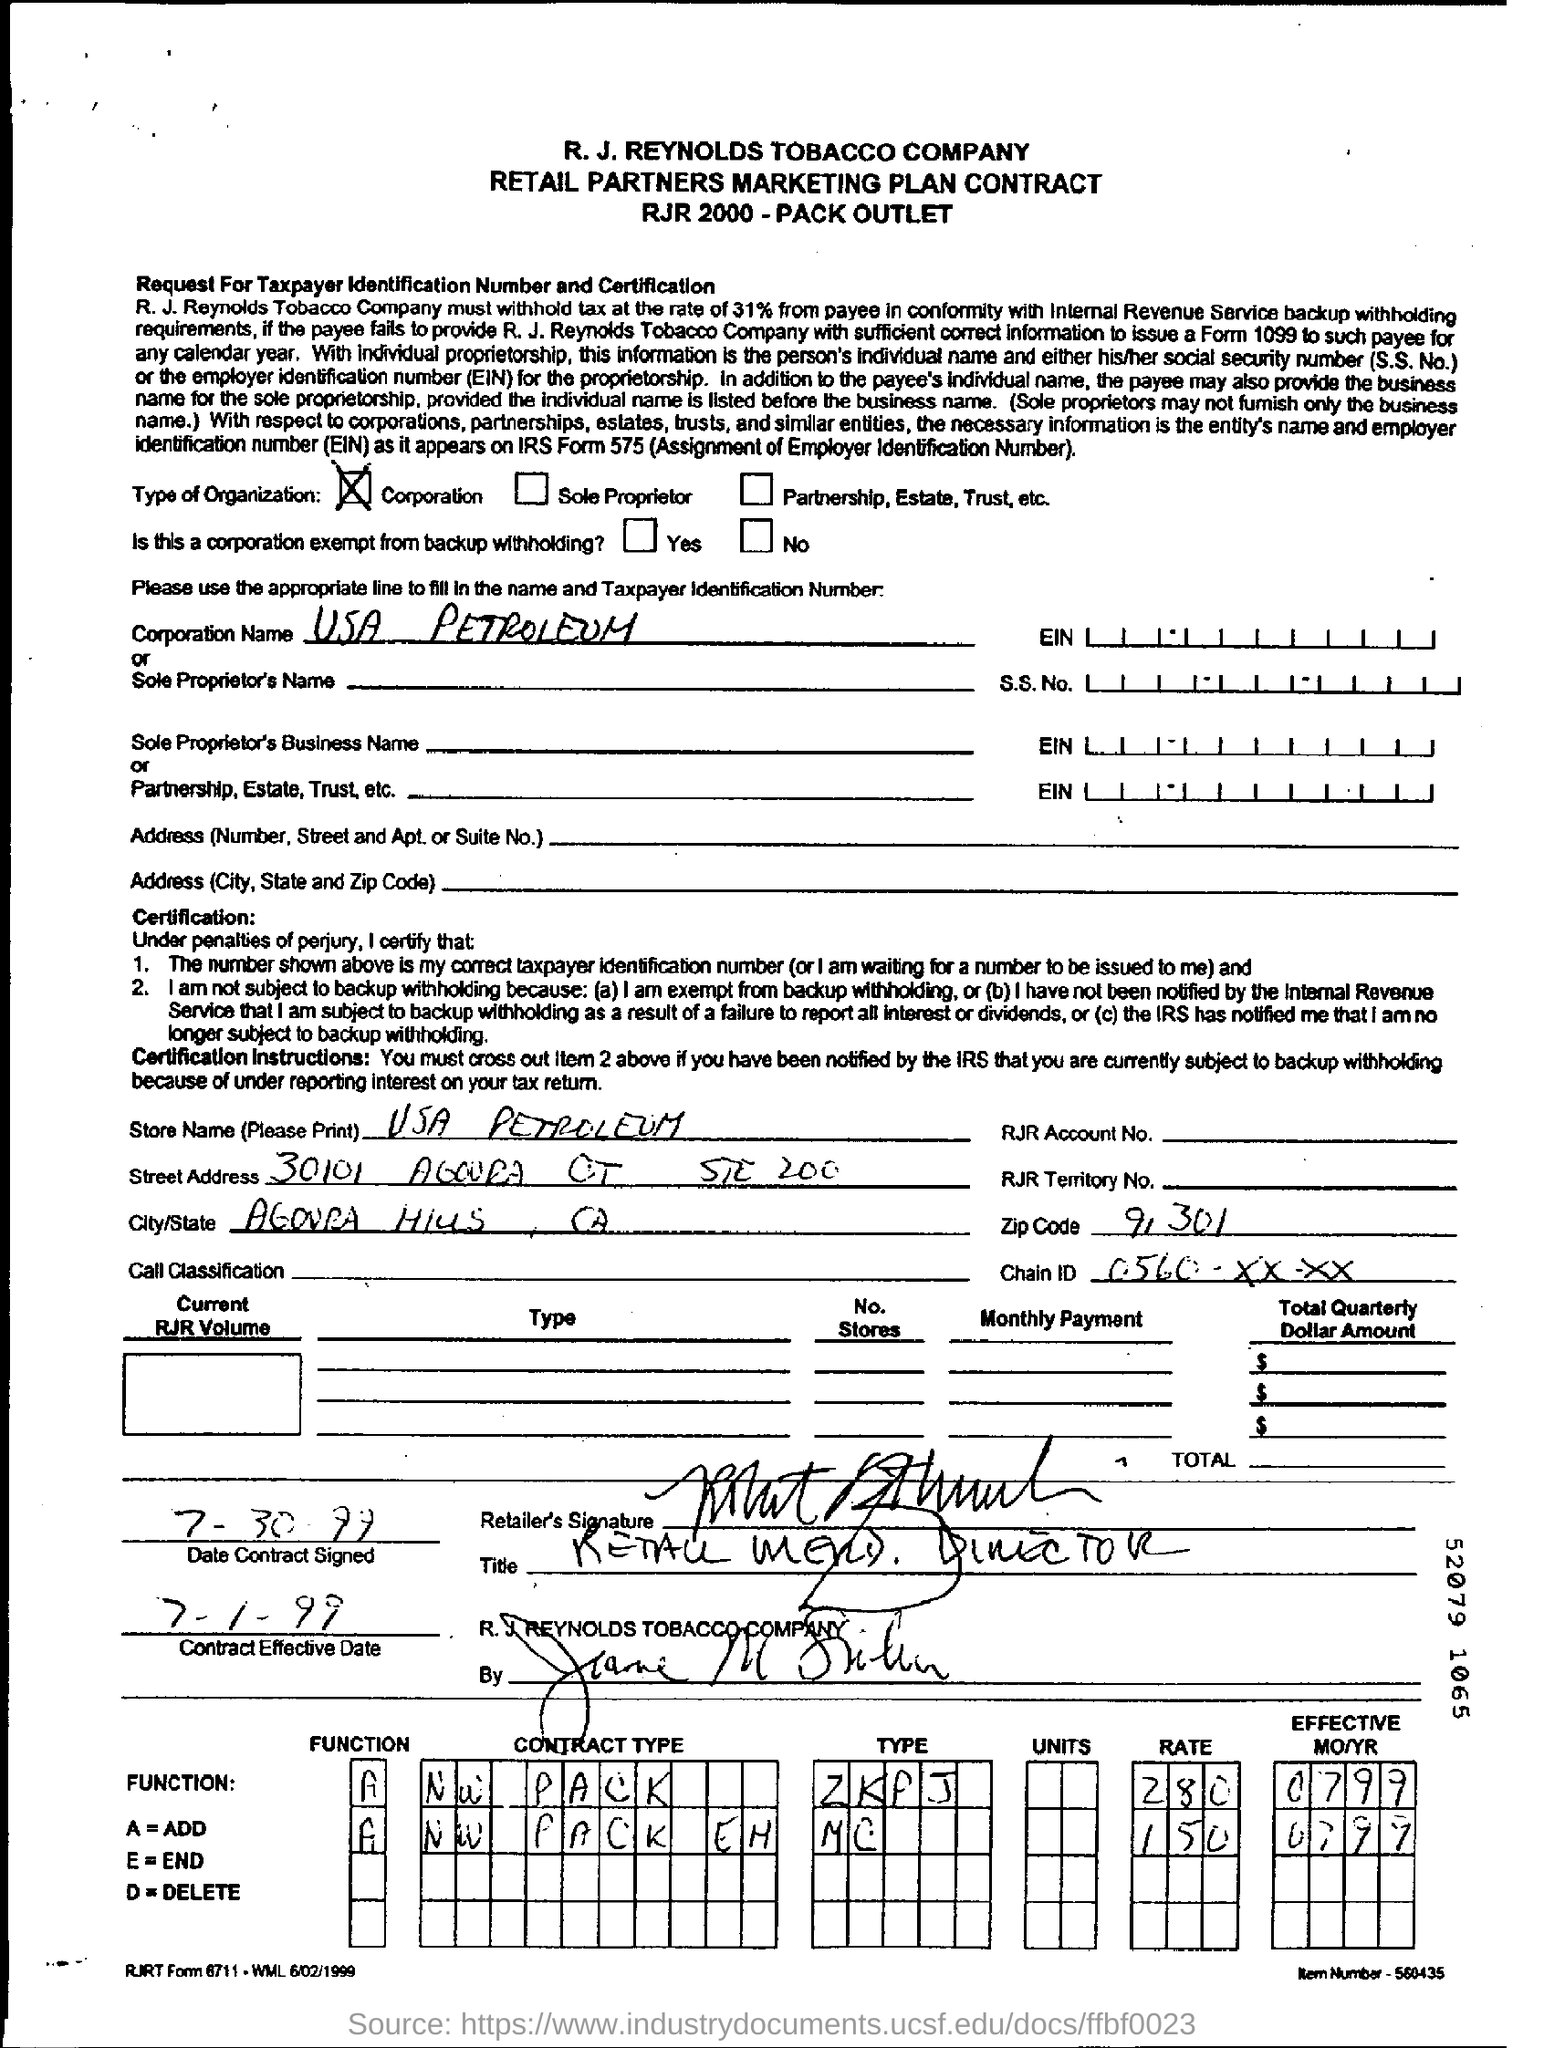What is written in the Zip code Field ?
Keep it short and to the point. 91301. What is the Contract Effective Date ?
Your answer should be compact. 7-1-99. 